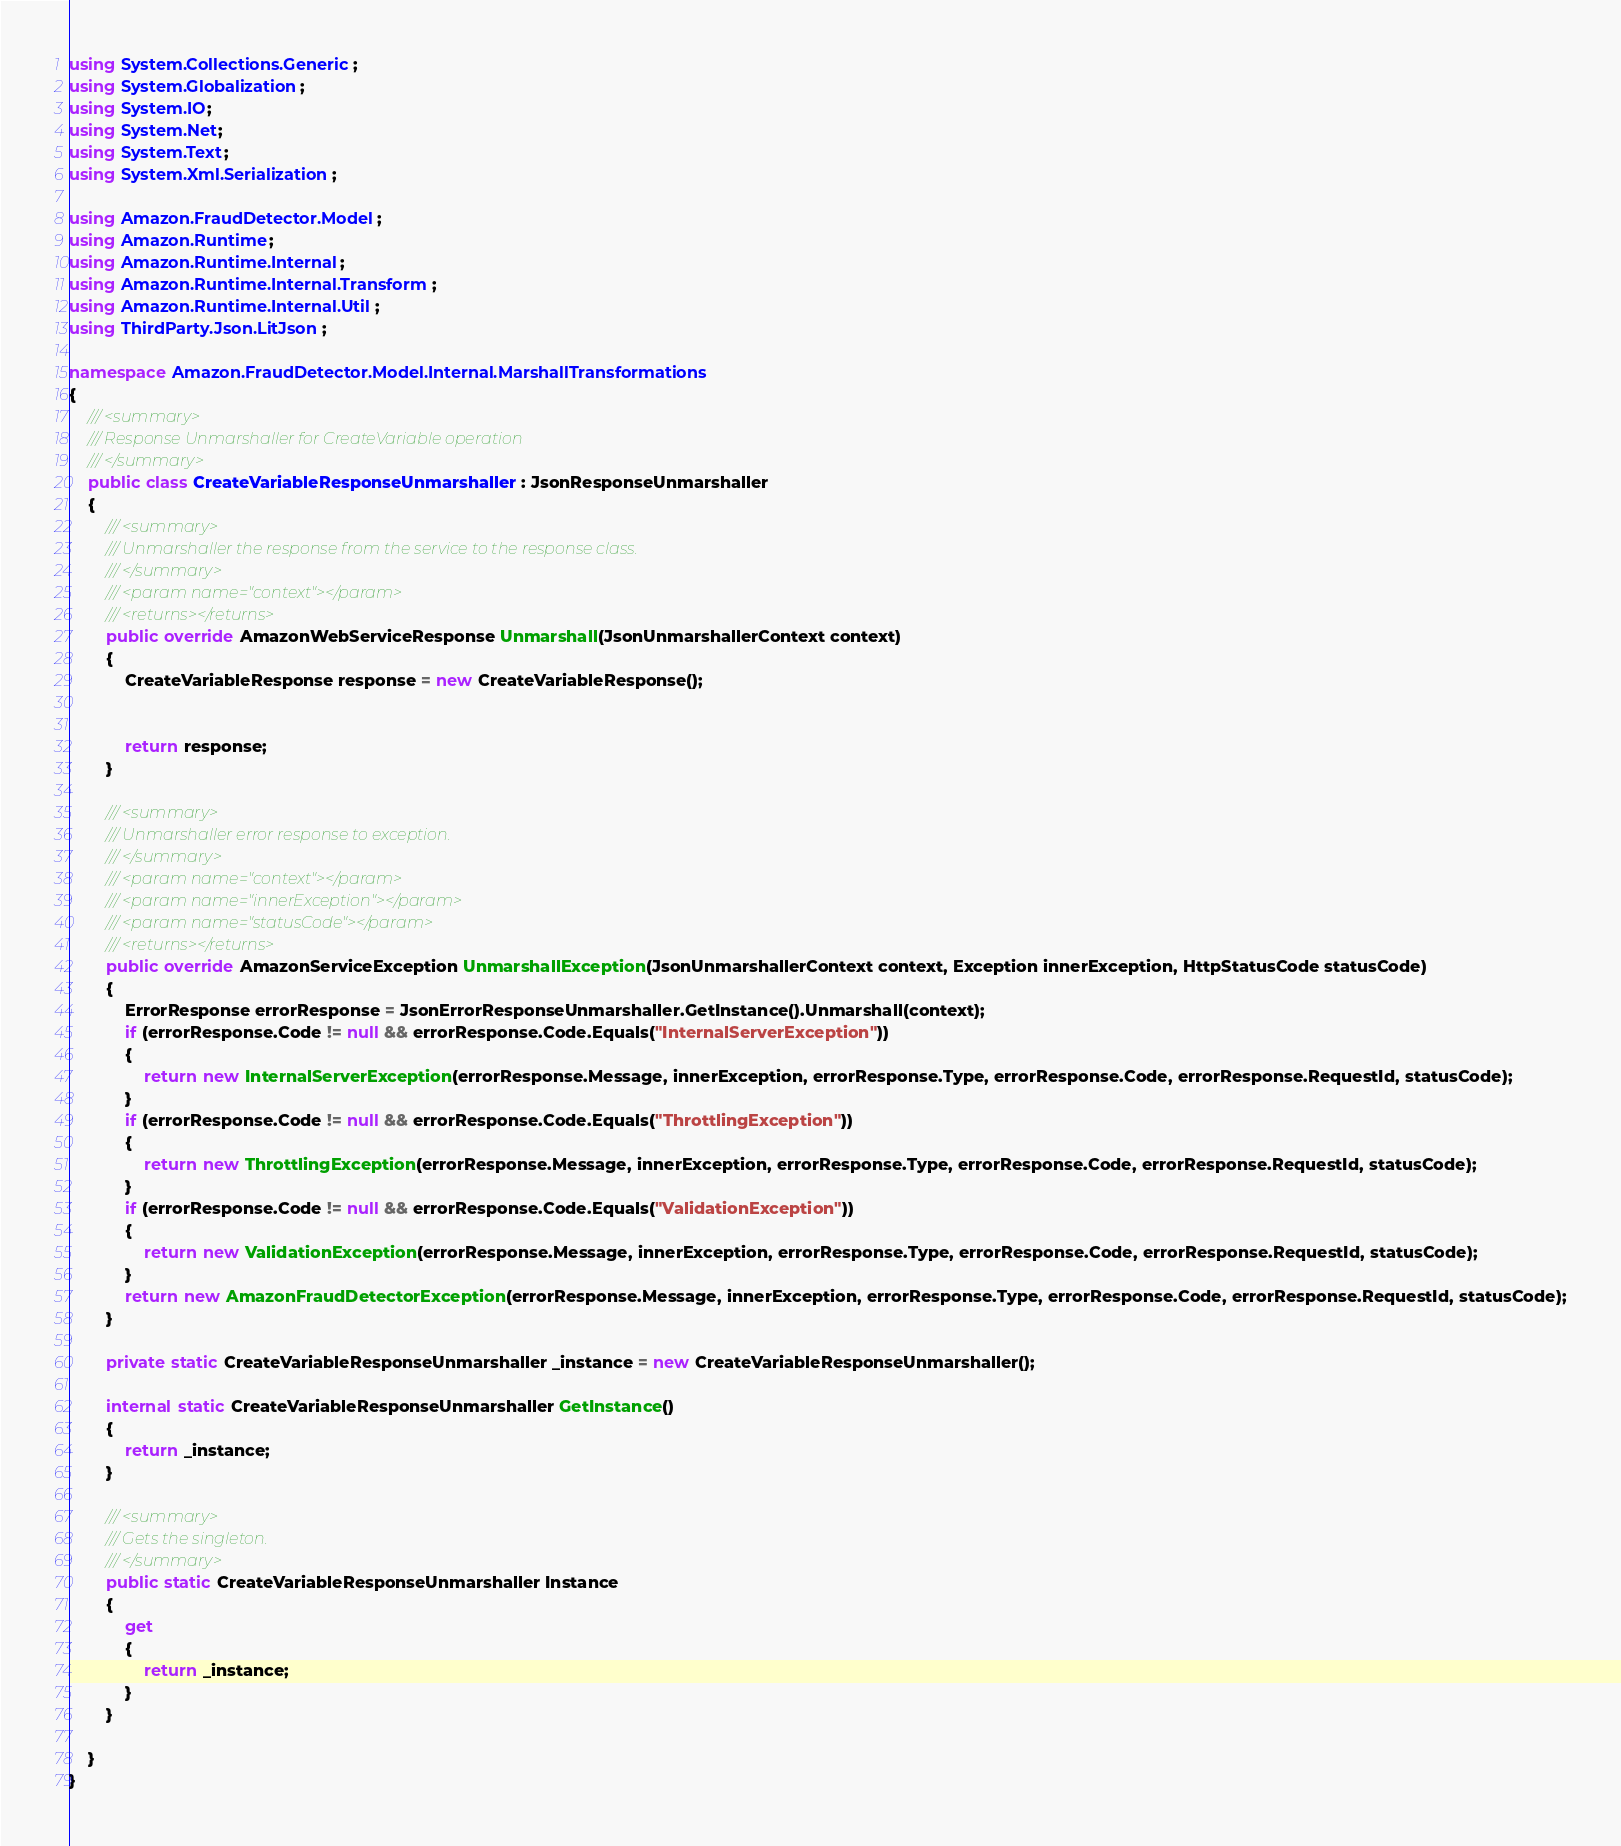Convert code to text. <code><loc_0><loc_0><loc_500><loc_500><_C#_>using System.Collections.Generic;
using System.Globalization;
using System.IO;
using System.Net;
using System.Text;
using System.Xml.Serialization;

using Amazon.FraudDetector.Model;
using Amazon.Runtime;
using Amazon.Runtime.Internal;
using Amazon.Runtime.Internal.Transform;
using Amazon.Runtime.Internal.Util;
using ThirdParty.Json.LitJson;

namespace Amazon.FraudDetector.Model.Internal.MarshallTransformations
{
    /// <summary>
    /// Response Unmarshaller for CreateVariable operation
    /// </summary>  
    public class CreateVariableResponseUnmarshaller : JsonResponseUnmarshaller
    {
        /// <summary>
        /// Unmarshaller the response from the service to the response class.
        /// </summary>  
        /// <param name="context"></param>
        /// <returns></returns>
        public override AmazonWebServiceResponse Unmarshall(JsonUnmarshallerContext context)
        {
            CreateVariableResponse response = new CreateVariableResponse();


            return response;
        }

        /// <summary>
        /// Unmarshaller error response to exception.
        /// </summary>  
        /// <param name="context"></param>
        /// <param name="innerException"></param>
        /// <param name="statusCode"></param>
        /// <returns></returns>
        public override AmazonServiceException UnmarshallException(JsonUnmarshallerContext context, Exception innerException, HttpStatusCode statusCode)
        {
            ErrorResponse errorResponse = JsonErrorResponseUnmarshaller.GetInstance().Unmarshall(context);
            if (errorResponse.Code != null && errorResponse.Code.Equals("InternalServerException"))
            {
                return new InternalServerException(errorResponse.Message, innerException, errorResponse.Type, errorResponse.Code, errorResponse.RequestId, statusCode);
            }
            if (errorResponse.Code != null && errorResponse.Code.Equals("ThrottlingException"))
            {
                return new ThrottlingException(errorResponse.Message, innerException, errorResponse.Type, errorResponse.Code, errorResponse.RequestId, statusCode);
            }
            if (errorResponse.Code != null && errorResponse.Code.Equals("ValidationException"))
            {
                return new ValidationException(errorResponse.Message, innerException, errorResponse.Type, errorResponse.Code, errorResponse.RequestId, statusCode);
            }
            return new AmazonFraudDetectorException(errorResponse.Message, innerException, errorResponse.Type, errorResponse.Code, errorResponse.RequestId, statusCode);
        }

        private static CreateVariableResponseUnmarshaller _instance = new CreateVariableResponseUnmarshaller();        

        internal static CreateVariableResponseUnmarshaller GetInstance()
        {
            return _instance;
        }

        /// <summary>
        /// Gets the singleton.
        /// </summary>  
        public static CreateVariableResponseUnmarshaller Instance
        {
            get
            {
                return _instance;
            }
        }

    }
}</code> 